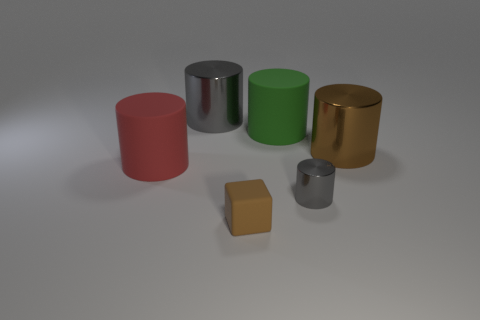What material is the big object that is the same color as the tiny cylinder?
Your answer should be compact. Metal. Is the material of the brown object to the left of the green object the same as the big red cylinder?
Your answer should be very brief. Yes. Is there a large thing of the same color as the small shiny thing?
Provide a succinct answer. Yes. What is the shape of the big red thing?
Provide a short and direct response. Cylinder. The matte cylinder that is on the left side of the gray shiny object on the left side of the small metallic thing is what color?
Provide a short and direct response. Red. There is a gray cylinder that is left of the green cylinder; what size is it?
Provide a succinct answer. Large. Are there any big red objects that have the same material as the block?
Your answer should be compact. Yes. What number of other small shiny objects are the same shape as the red object?
Give a very brief answer. 1. What shape is the large metallic thing left of the big matte cylinder that is to the right of the big metallic cylinder to the left of the tiny gray cylinder?
Your answer should be very brief. Cylinder. There is a large object that is both behind the large brown metallic thing and left of the small rubber object; what is it made of?
Provide a short and direct response. Metal. 